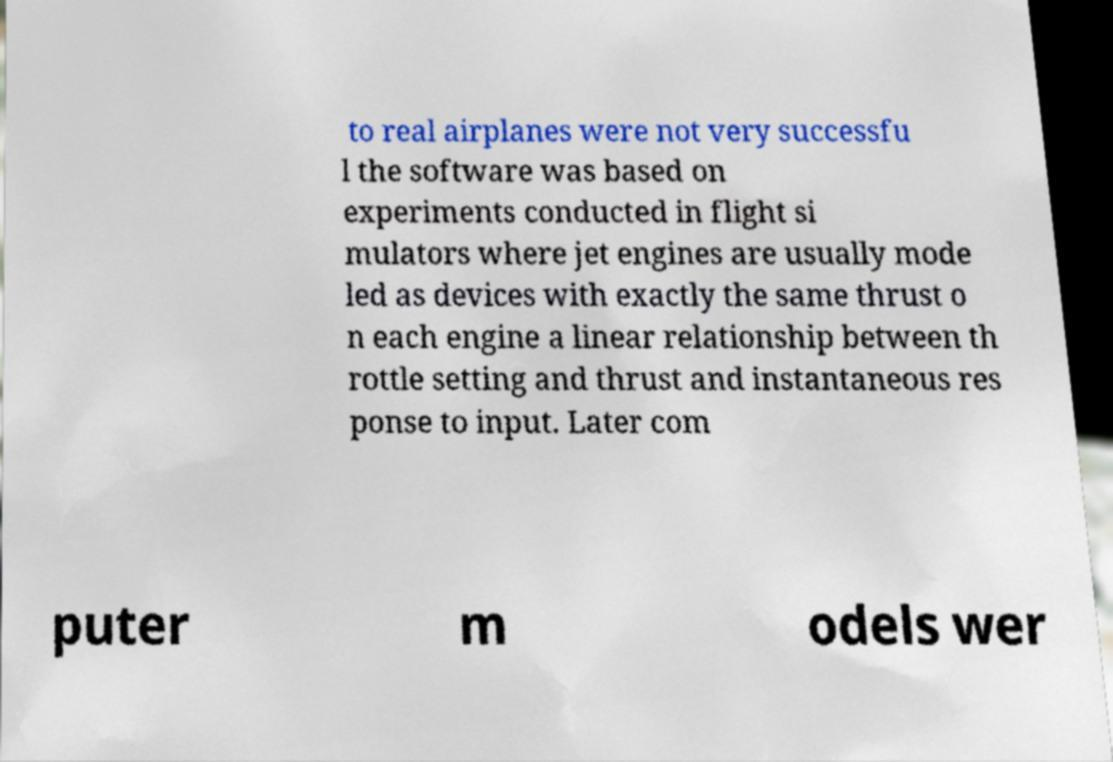There's text embedded in this image that I need extracted. Can you transcribe it verbatim? to real airplanes were not very successfu l the software was based on experiments conducted in flight si mulators where jet engines are usually mode led as devices with exactly the same thrust o n each engine a linear relationship between th rottle setting and thrust and instantaneous res ponse to input. Later com puter m odels wer 